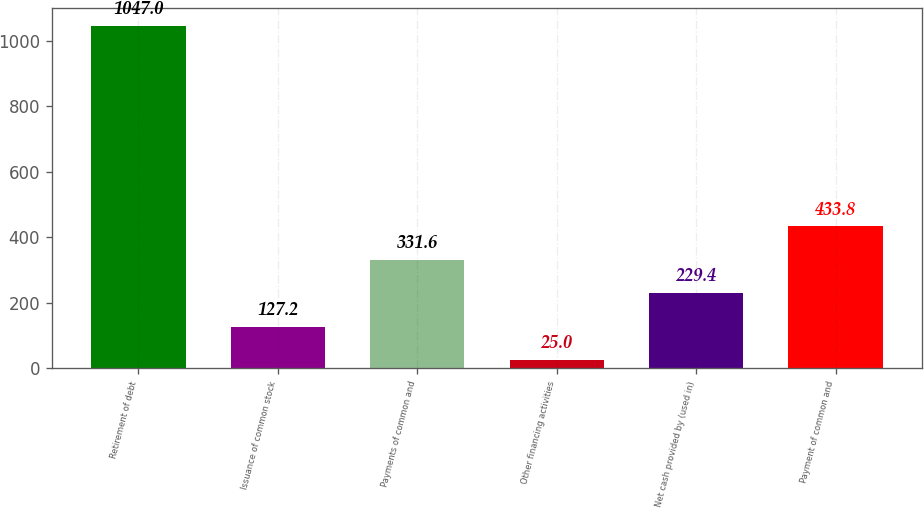Convert chart. <chart><loc_0><loc_0><loc_500><loc_500><bar_chart><fcel>Retirement of debt<fcel>Issuance of common stock<fcel>Payments of common and<fcel>Other financing activities<fcel>Net cash provided by (used in)<fcel>Payment of common and<nl><fcel>1047<fcel>127.2<fcel>331.6<fcel>25<fcel>229.4<fcel>433.8<nl></chart> 